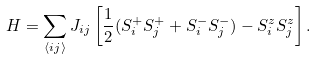Convert formula to latex. <formula><loc_0><loc_0><loc_500><loc_500>H = \sum _ { \langle i j \rangle } J _ { i j } \left [ \frac { 1 } { 2 } ( S _ { i } ^ { + } S _ { j } ^ { + } + S _ { i } ^ { - } S _ { j } ^ { - } ) - S _ { i } ^ { z } S _ { j } ^ { z } \right ] .</formula> 